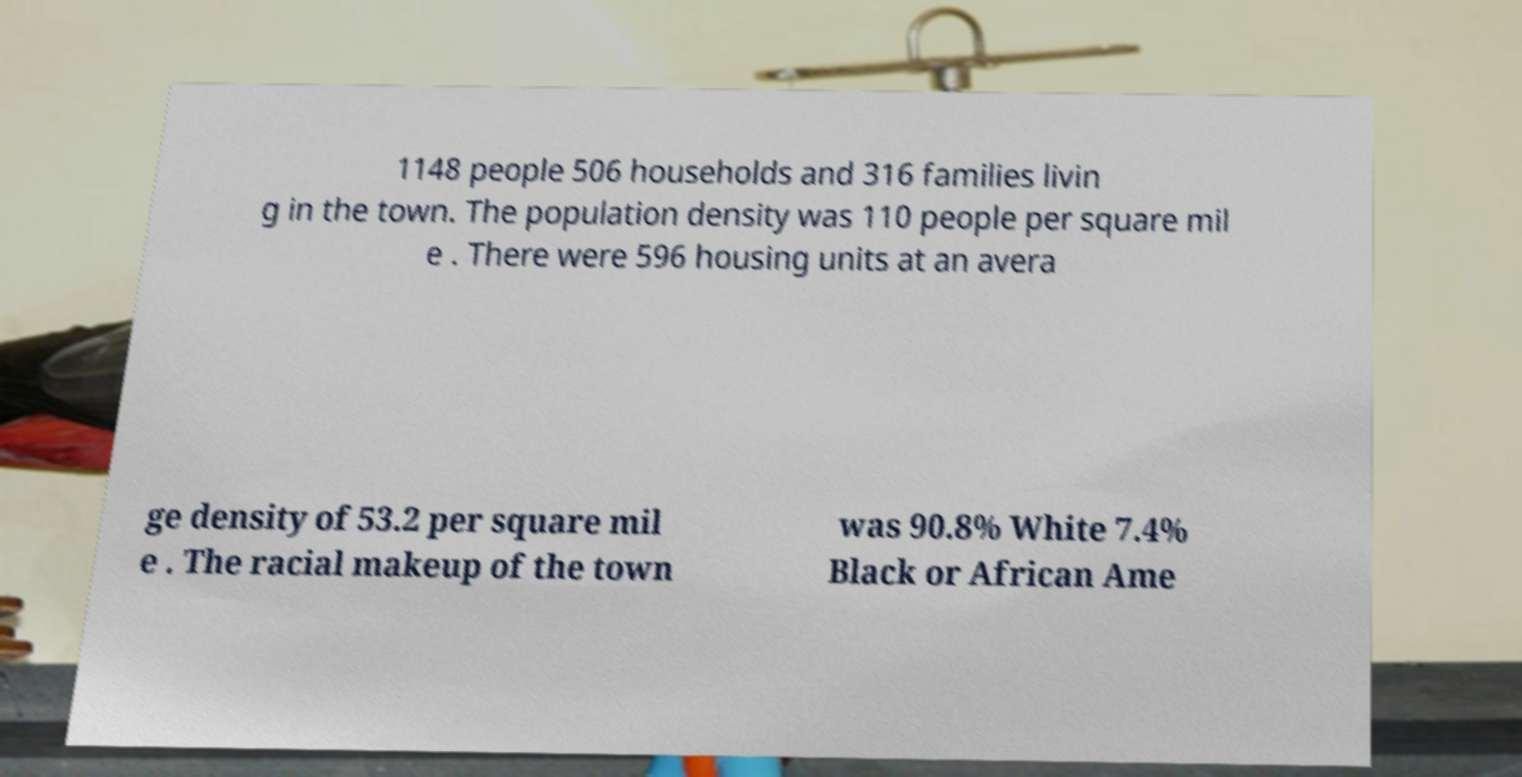Could you assist in decoding the text presented in this image and type it out clearly? 1148 people 506 households and 316 families livin g in the town. The population density was 110 people per square mil e . There were 596 housing units at an avera ge density of 53.2 per square mil e . The racial makeup of the town was 90.8% White 7.4% Black or African Ame 